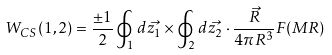Convert formula to latex. <formula><loc_0><loc_0><loc_500><loc_500>W _ { C S } ( 1 , 2 ) = \frac { \pm 1 } { 2 } \oint _ { 1 } d \vec { z _ { 1 } } \times \oint _ { 2 } d \vec { z _ { 2 } } \cdot \frac { \vec { R } } { 4 \pi R ^ { 3 } } F ( M R )</formula> 